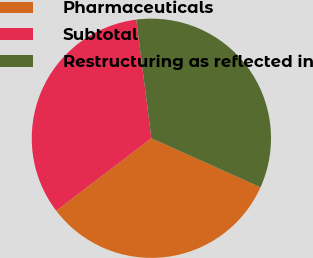Convert chart to OTSL. <chart><loc_0><loc_0><loc_500><loc_500><pie_chart><fcel>Pharmaceuticals<fcel>Subtotal<fcel>Restructuring as reflected in<nl><fcel>32.92%<fcel>33.33%<fcel>33.74%<nl></chart> 